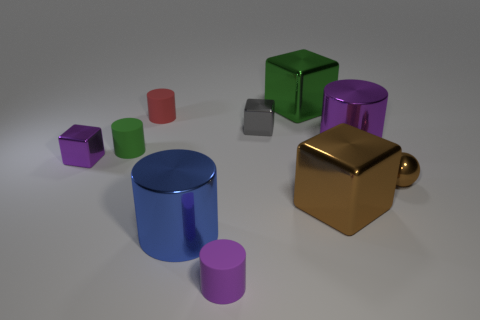What number of objects are there?
Your answer should be compact. 10. What is the shape of the object that is the same color as the small shiny ball?
Your response must be concise. Cube. There is a green shiny thing that is the same shape as the gray object; what is its size?
Offer a very short reply. Large. Is the shape of the purple thing that is in front of the brown shiny cube the same as  the tiny green thing?
Make the answer very short. Yes. There is a large cube that is behind the brown shiny sphere; what color is it?
Offer a very short reply. Green. What number of other objects are there of the same size as the red matte cylinder?
Ensure brevity in your answer.  5. Are there any other things that have the same shape as the small brown object?
Ensure brevity in your answer.  No. Are there an equal number of tiny purple shiny things behind the small red matte cylinder and cylinders?
Give a very brief answer. No. How many brown objects have the same material as the big blue cylinder?
Your answer should be compact. 2. What is the color of the small sphere that is the same material as the small purple block?
Provide a succinct answer. Brown. 